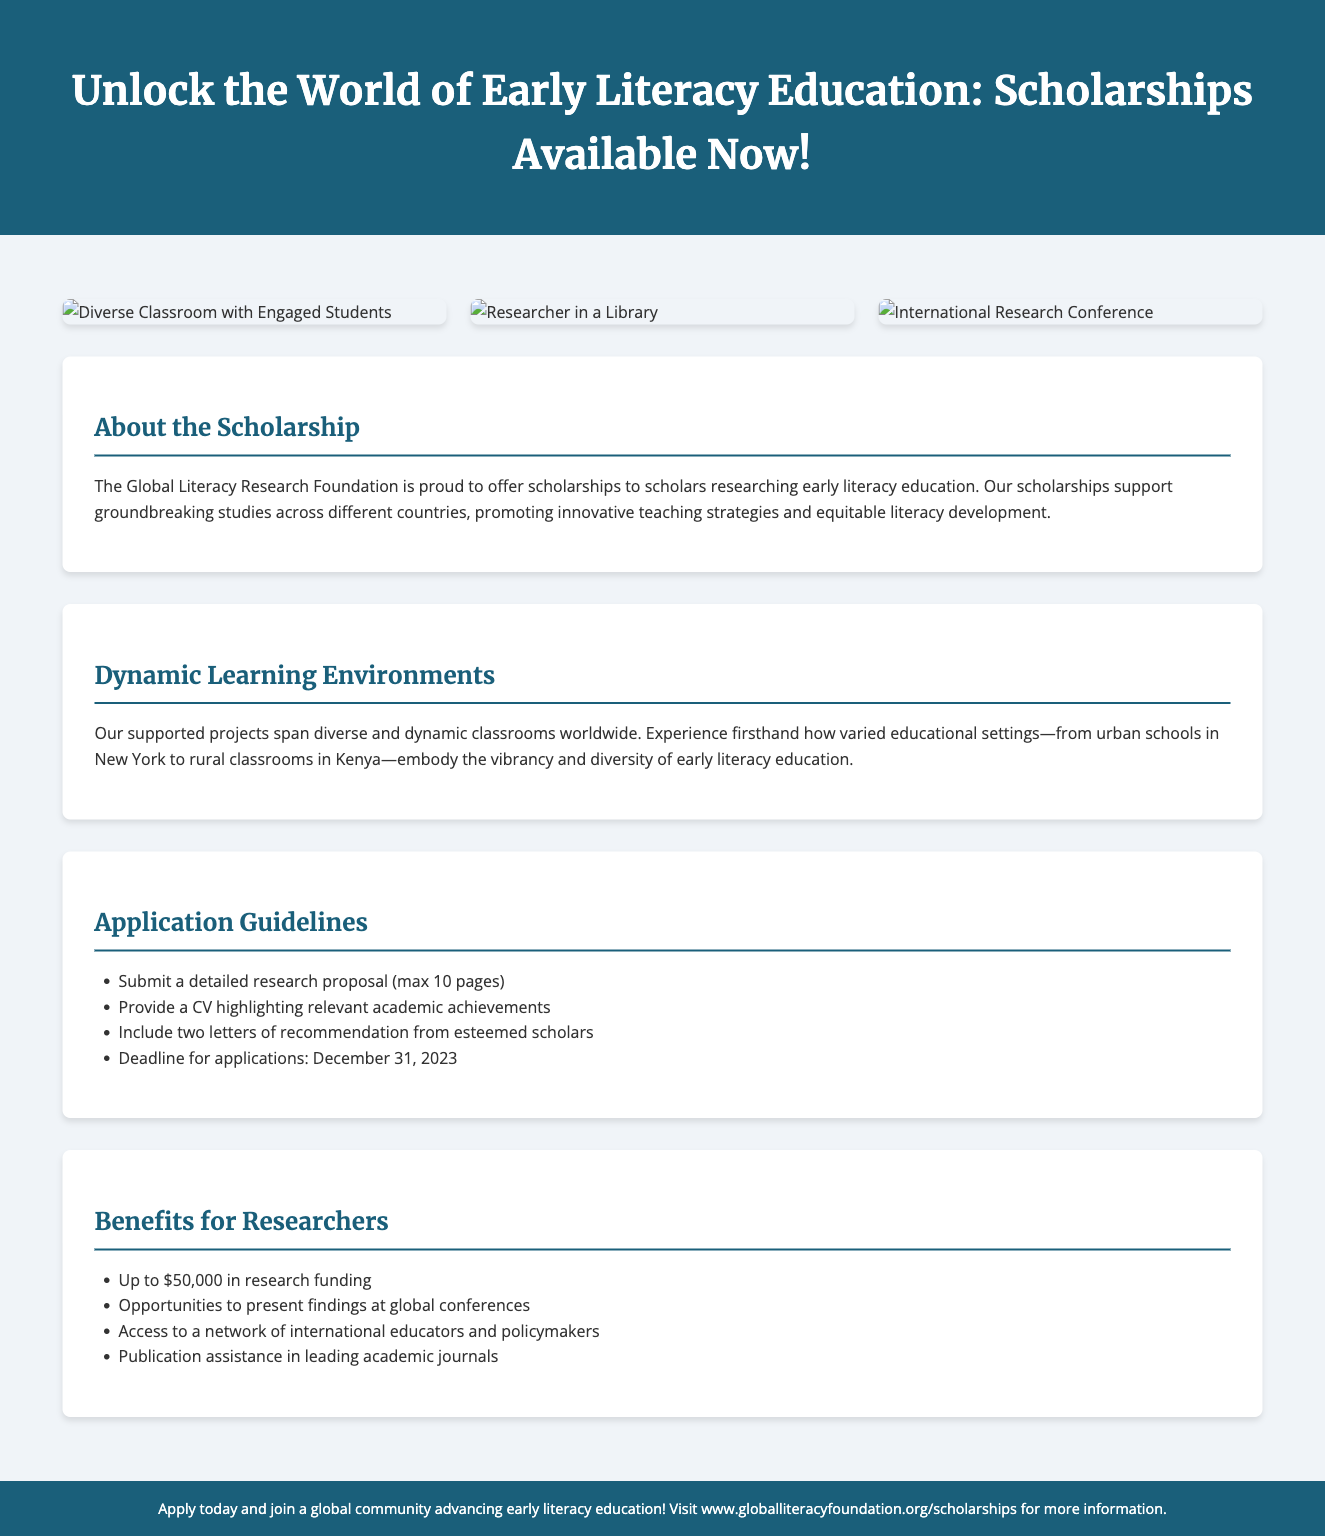What is the scholarship offered by? The scholarship is offered by the Global Literacy Research Foundation, which is mentioned in the "About the Scholarship" section.
Answer: Global Literacy Research Foundation What is the maximum length for the research proposal? The application guidelines specify that the research proposal should be a maximum of 10 pages.
Answer: 10 pages What is the deadline for applications? The document mentions the deadline for applications clearly as December 31, 2023.
Answer: December 31, 2023 How much funding can researchers receive? The benefits for researchers state they can receive up to $50,000 in research funding.
Answer: $50,000 What should be included along with the research proposal? The application guidelines require a CV highlighting relevant academic achievements to be included with the research proposal.
Answer: CV What opportunities do scholarship recipients have for presenting their findings? The "Benefits for Researchers" section indicates that there are opportunities to present findings at global conferences.
Answer: Global conferences What type of classrooms are highlighted in the scholarship's supported projects? The document emphasizes diverse and dynamic classrooms worldwide in the "Dynamic Learning Environments" section.
Answer: Diverse and dynamic classrooms How many letters of recommendation are required? According to the application guidelines, two letters of recommendation are required from esteemed scholars.
Answer: Two letters 